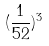<formula> <loc_0><loc_0><loc_500><loc_500>( \frac { 1 } { 5 2 } ) ^ { 3 }</formula> 